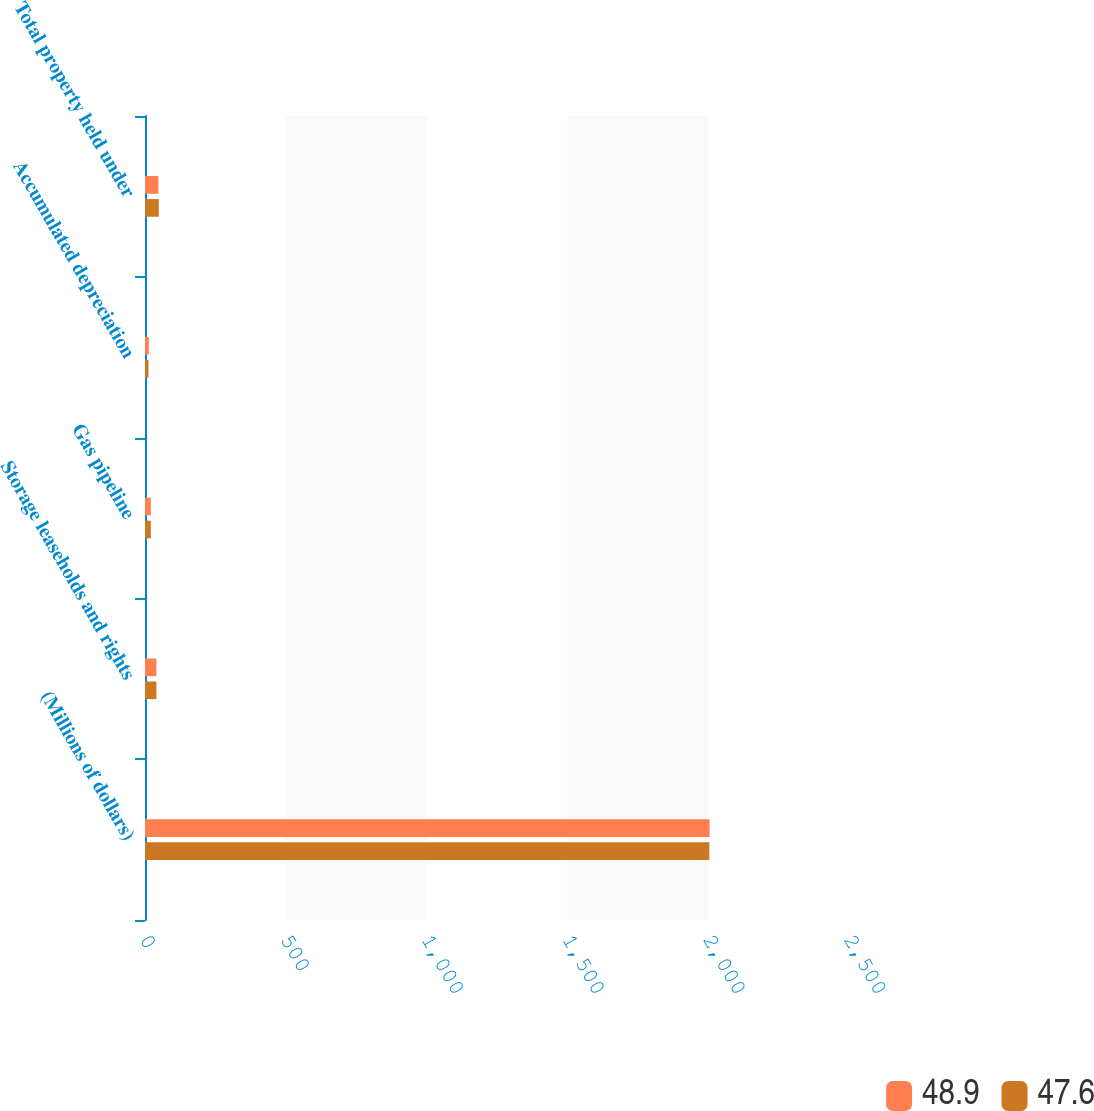<chart> <loc_0><loc_0><loc_500><loc_500><stacked_bar_chart><ecel><fcel>(Millions of dollars)<fcel>Storage leaseholds and rights<fcel>Gas pipeline<fcel>Accumulated depreciation<fcel>Total property held under<nl><fcel>48.9<fcel>2005<fcel>40.5<fcel>20.7<fcel>13.6<fcel>47.6<nl><fcel>47.6<fcel>2004<fcel>40.5<fcel>20.7<fcel>12.3<fcel>48.9<nl></chart> 